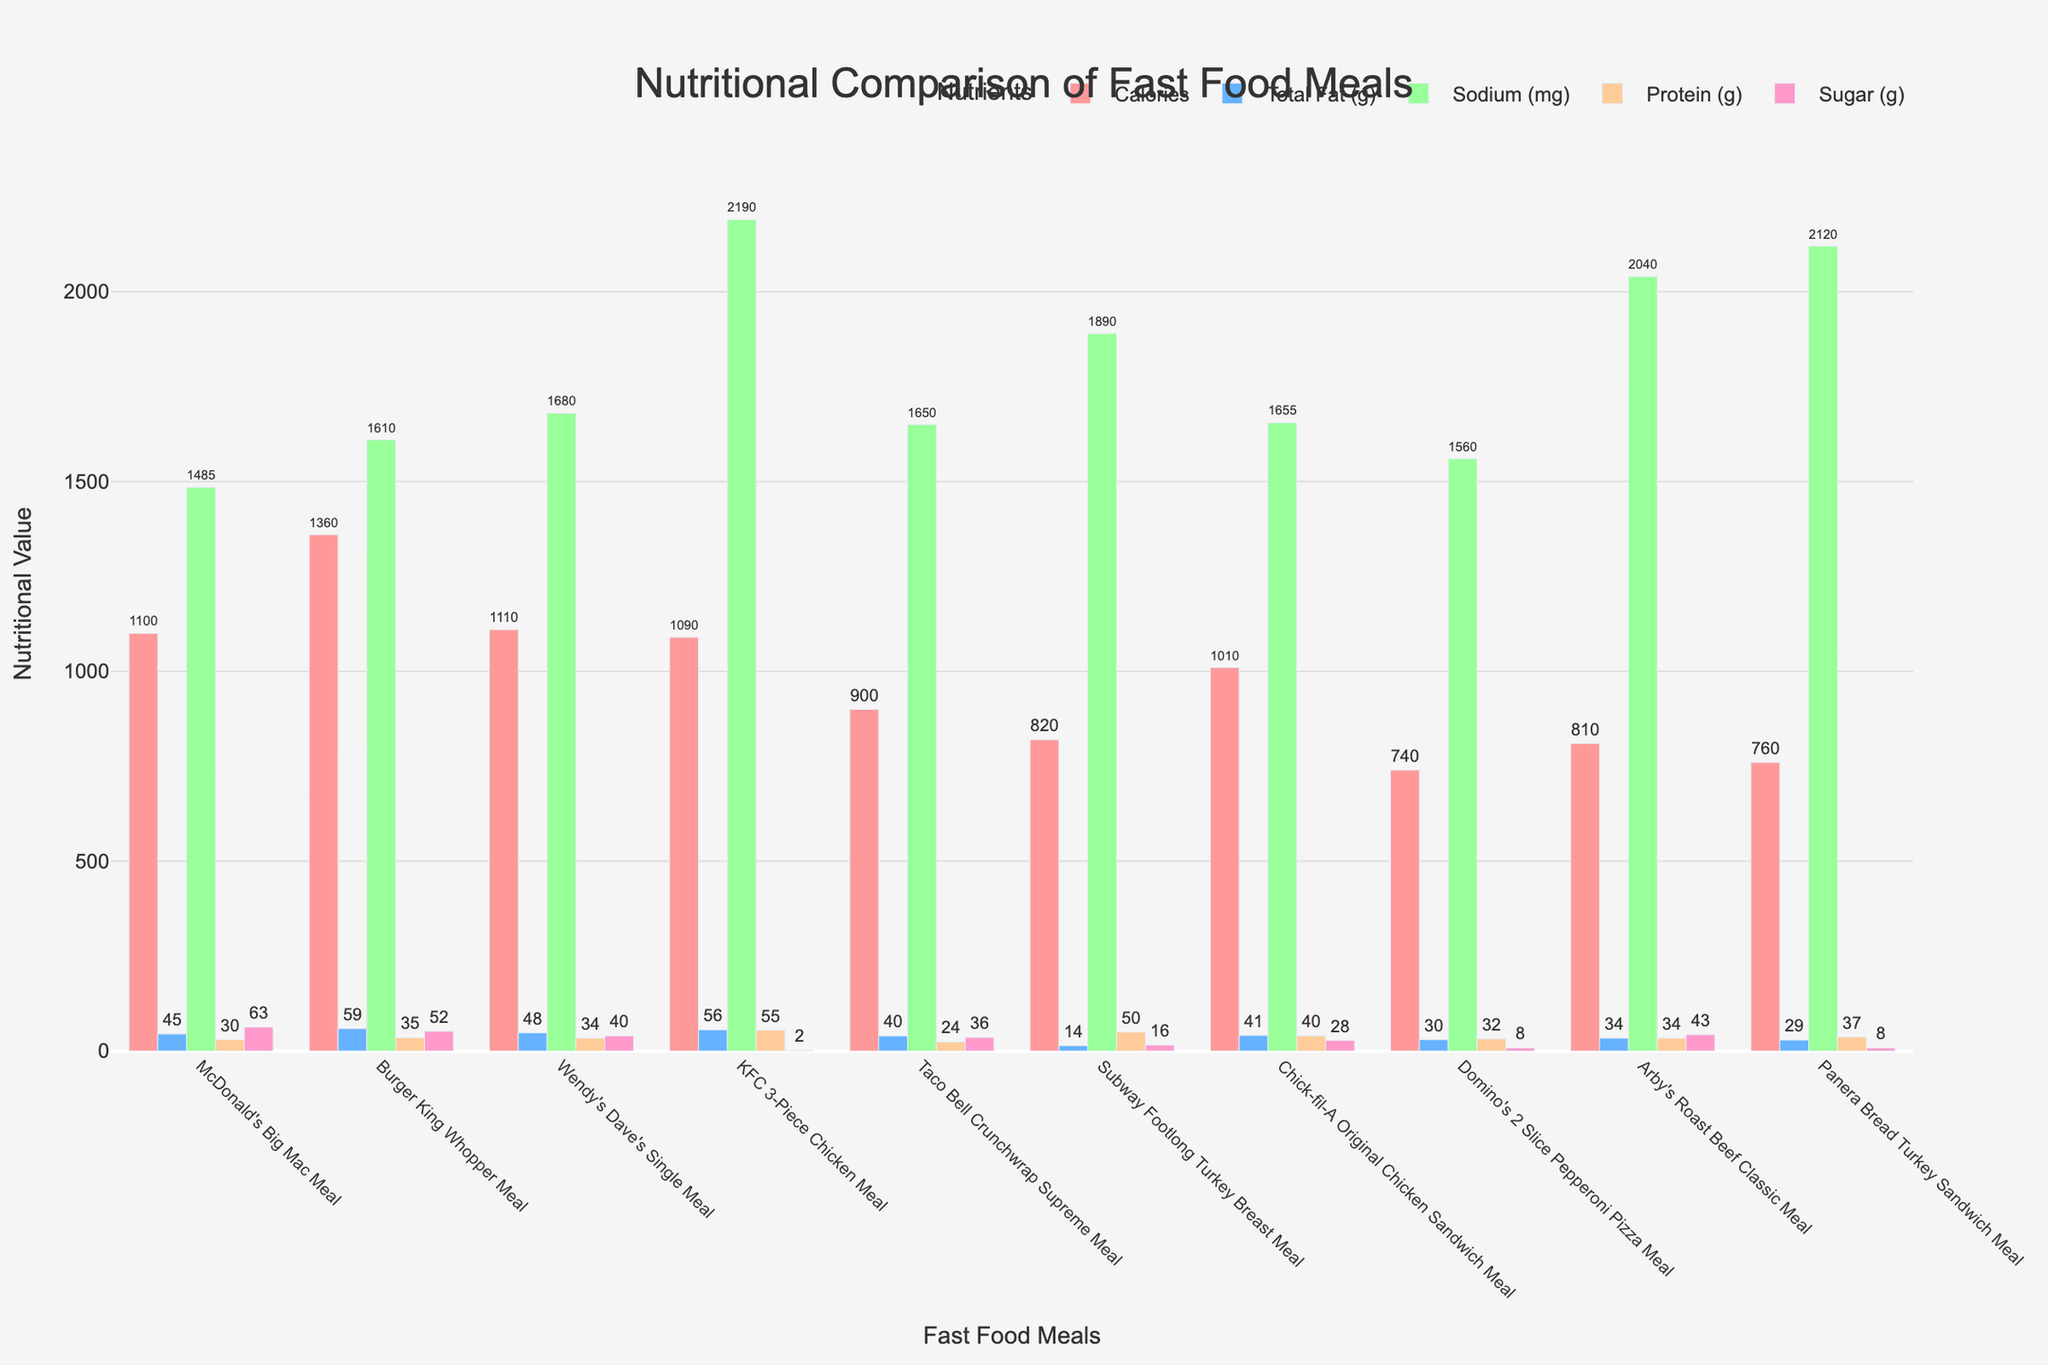What's the total calories for McDonald's Big Mac Meal and Wendy's Dave's Single Meal combined? Add the calories: 1100 (McDonald's) + 1110 (Wendy's) = 2210
Answer: 2210 Which meal has the highest sugar content? The Wendy's Dave's Single Meal has 40g of sugar, KFC 3-Piece Chicken Meal has 2g, and so forth for each meal, identifying Burger King Whopper Meal with 52g as the highest.
Answer: Burger King Whopper Meal Comparing McDonald's Big Mac Meal and Subway Footlong Turkey Breast Meal, which meal has more protein? The protein content of McDonald's is 30g and Subway's is 50g. Since 50g > 30g, Subway has more protein.
Answer: Subway Footlong Turkey Breast Meal What is the difference in sodium between Taco Bell Crunchwrap Supreme Meal and Arby's Roast Beef Classic Meal? The sodium content is 1650mg for Taco Bell and 2040mg for Arby's. The difference is 2040mg - 1650mg = 390mg.
Answer: 390mg By how much does the Total Fat content in Burger King Whopper Meal exceed that in Panera Bread Turkey Sandwich Meal? Burger King's total fat is 59g and Panera's is 29g. The difference is 59g - 29g = 30g.
Answer: 30g If I choose meals with Calories less than 1000, which meals qualify? Identify meals: Taco Bell with 900 Calories, Subway with 820, Domino's with 740, and Arby’s with 810. All are less than 1000.
Answer: Taco Bell Crunchwrap Supreme Meal, Subway Footlong Turkey Breast Meal, Domino's 2 Slice Pepperoni Pizza Meal, Arby's Roast Beef Classic Meal Which meal has the least Total Fat but highest Protein? Subway has the least Total Fat of 14g and high protein of 50g. Other meals either have higher fat or lower protein.
Answer: Subway Footlong Turkey Breast Meal Which two meals have the same Sugar content of 8g? Compare sugar content: Domino's and Panera Bread Turkey Sandwich both have 8g of sugar.
Answer: Domino's 2 Slice Pepperoni Pizza Meal, Panera Bread Turkey Sandwich Meal What is the average sugar content of all meals? Sum the sugar values (63+52+40+2+36+16+28+8+43+8) = 298; then divide by 10 (number of meals) to get 29.8g.
Answer: 29.8g In terms of Calories, which meals fall between 800 and 1100? Identify meals in this range: McDonald's with 1100, Wendy's with 1110, KFC with 1090, Chick-fil-A with 1010, and Subway with 820, Arby’s with 810, and Panera Bread with 760.
Answer: McDonald's Big Mac Meal, Wendy's Dave's Single Meal, KFC 3-Piece Chicken Meal, Chick-fil-A Original Chicken Sandwich Meal, Subway Footlong Turkey Breast Meal, Arby's Roast Beef Classic Meal, Panera Bread Turkey Sandwich Meal 